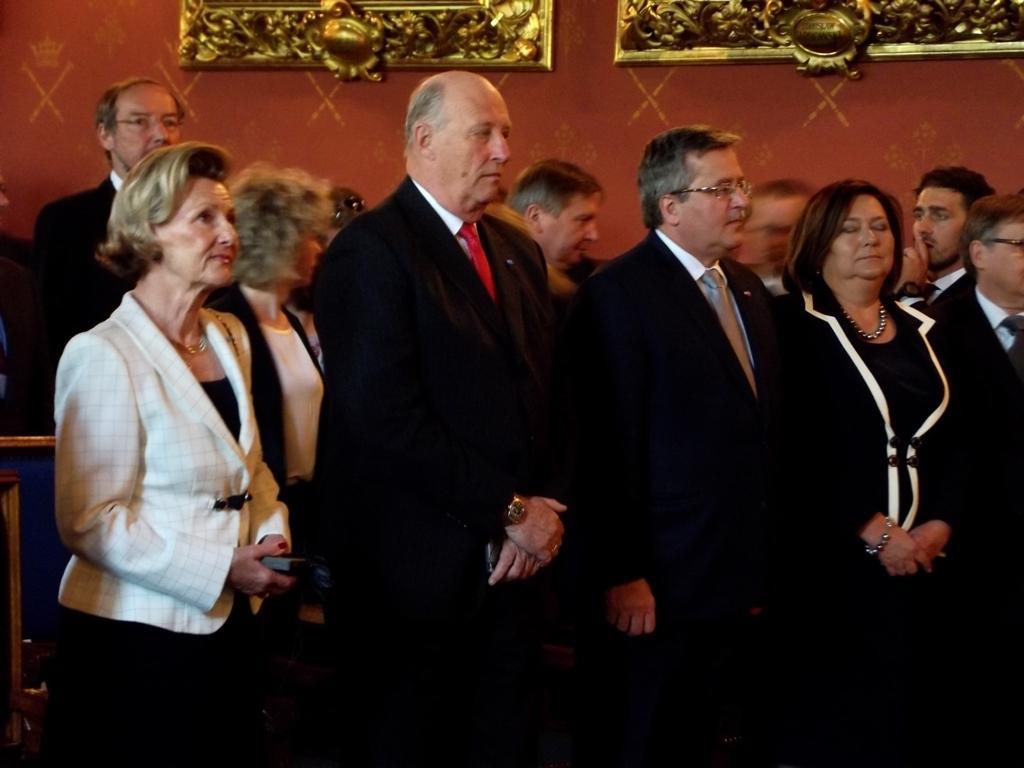Describe this image in one or two sentences. In the picture I can see people wearing black color blazers and a woman wearing white color blazer are standing here. In the background, we can see a few more people and we can see some golden color frames attached to the brown color wall. 